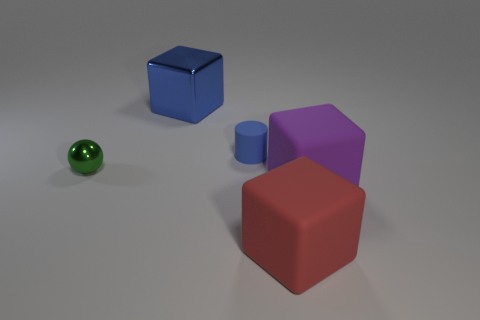Are there any other things that have the same size as the ball?
Your answer should be compact. Yes. There is a blue object right of the cube that is behind the small green metallic ball; how big is it?
Keep it short and to the point. Small. There is a purple thing that is the same size as the blue metal block; what is its material?
Your response must be concise. Rubber. Is there a small green cylinder that has the same material as the large purple thing?
Offer a terse response. No. There is a big block that is behind the metallic thing that is in front of the cube that is left of the big red rubber block; what color is it?
Your answer should be compact. Blue. There is a big cube that is behind the ball; does it have the same color as the small thing that is right of the metallic sphere?
Ensure brevity in your answer.  Yes. Are there any other things that are the same color as the rubber cylinder?
Offer a terse response. Yes. Are there fewer tiny shiny balls that are on the right side of the large purple matte object than large cubes?
Your answer should be compact. Yes. How many green rubber cylinders are there?
Your answer should be very brief. 0. There is a big purple object; is its shape the same as the large thing that is behind the tiny rubber object?
Ensure brevity in your answer.  Yes. 